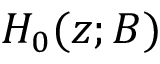<formula> <loc_0><loc_0><loc_500><loc_500>H _ { 0 } ( z ; B )</formula> 